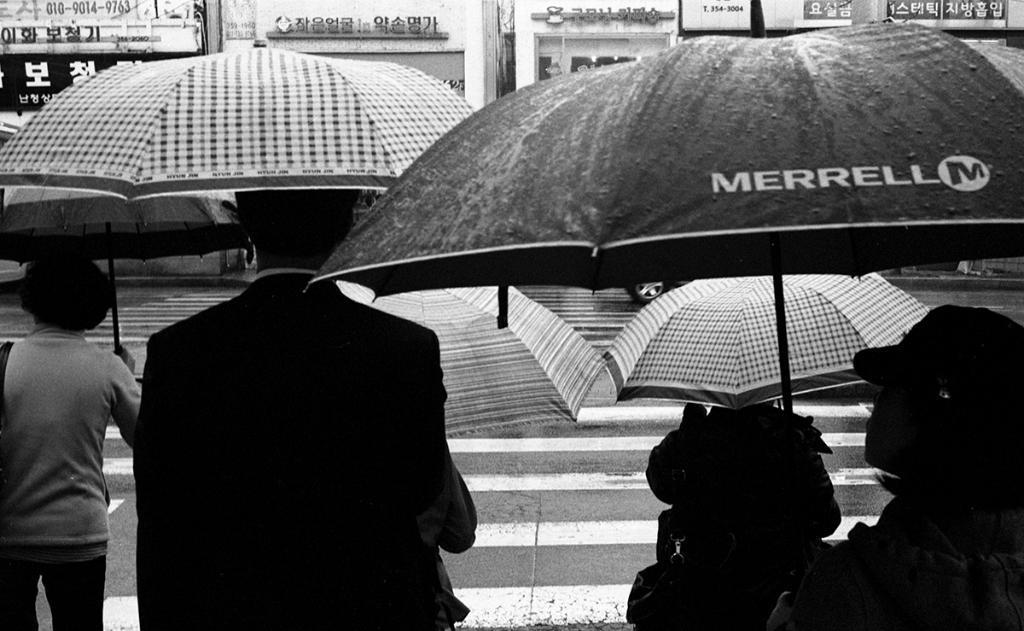Can you describe this image briefly? In the picture we can see some people are standing near the road holding some umbrellas and opposite to them we can see some buildings with shops. 